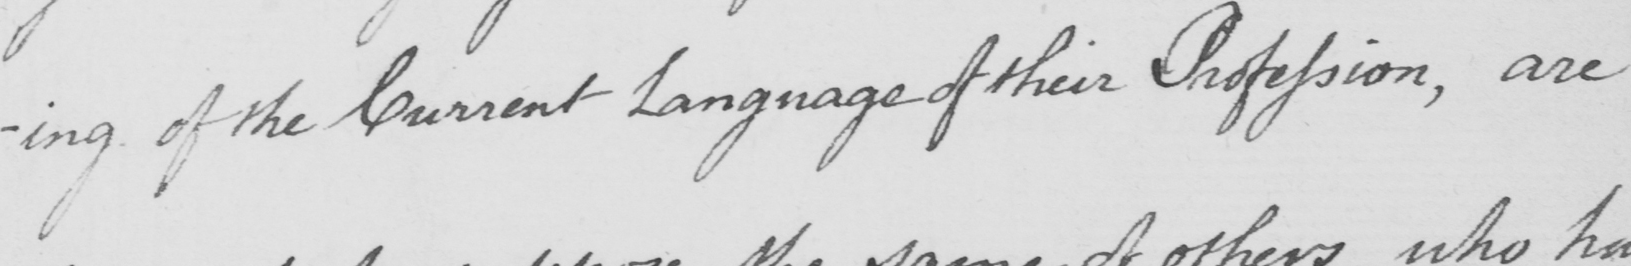Can you read and transcribe this handwriting? -ing of the Current Language of their Profession , are 